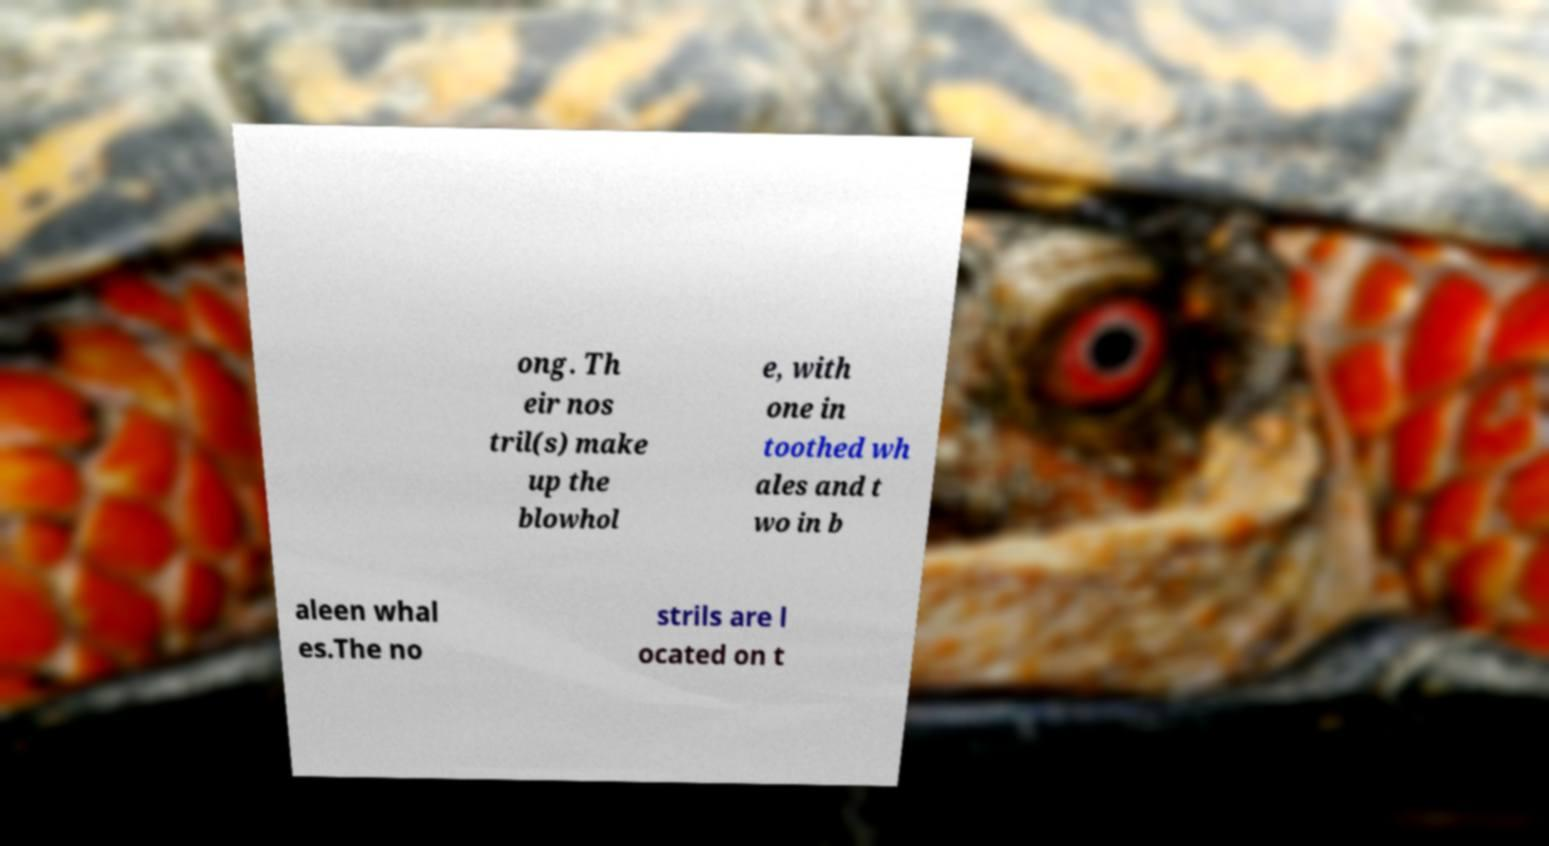What messages or text are displayed in this image? I need them in a readable, typed format. ong. Th eir nos tril(s) make up the blowhol e, with one in toothed wh ales and t wo in b aleen whal es.The no strils are l ocated on t 